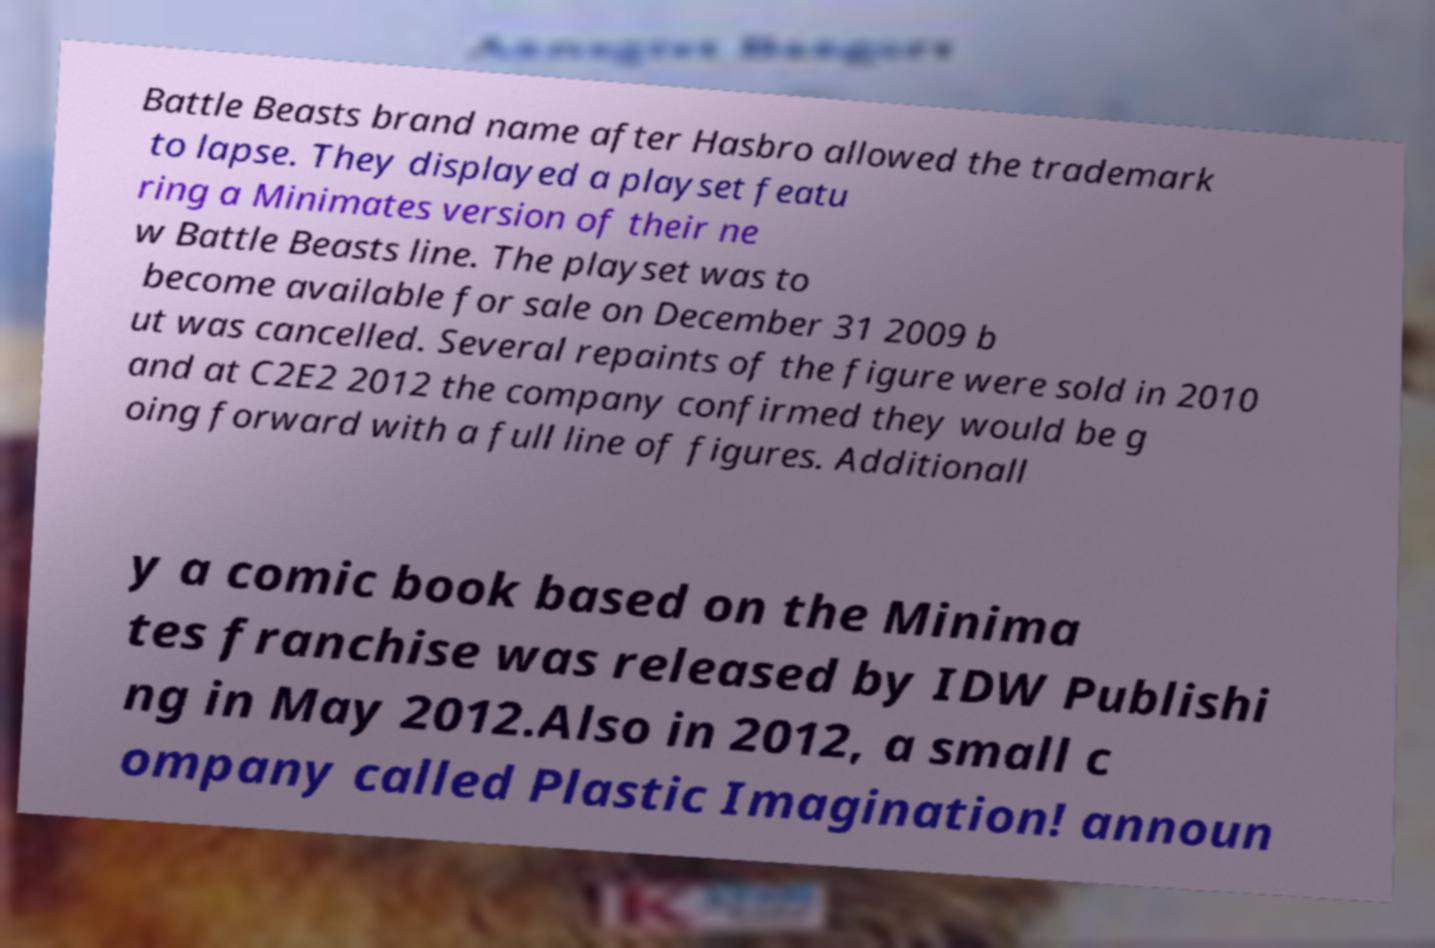Can you read and provide the text displayed in the image?This photo seems to have some interesting text. Can you extract and type it out for me? Battle Beasts brand name after Hasbro allowed the trademark to lapse. They displayed a playset featu ring a Minimates version of their ne w Battle Beasts line. The playset was to become available for sale on December 31 2009 b ut was cancelled. Several repaints of the figure were sold in 2010 and at C2E2 2012 the company confirmed they would be g oing forward with a full line of figures. Additionall y a comic book based on the Minima tes franchise was released by IDW Publishi ng in May 2012.Also in 2012, a small c ompany called Plastic Imagination! announ 